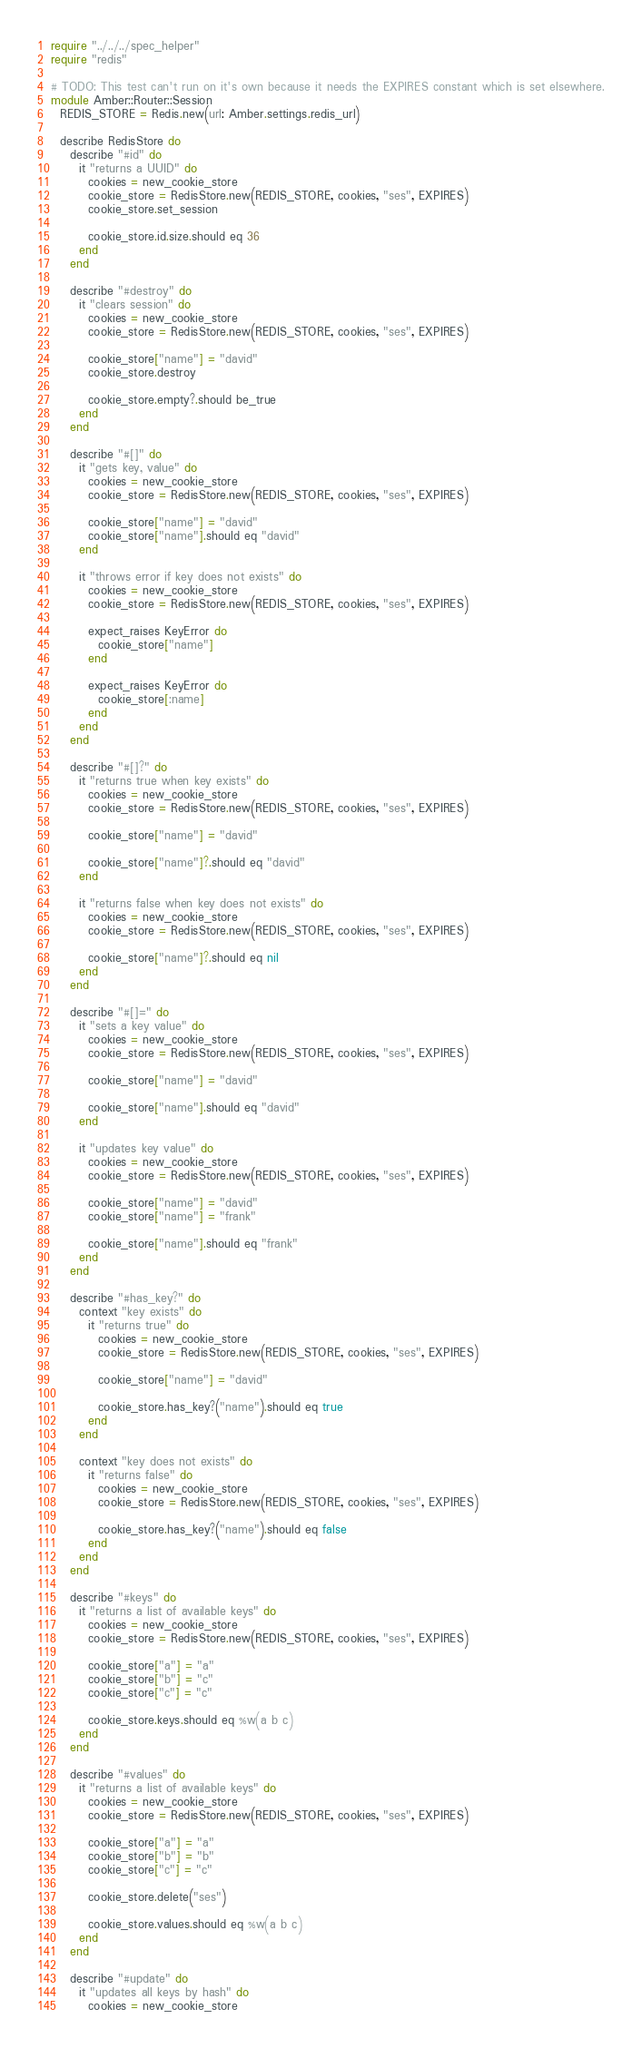<code> <loc_0><loc_0><loc_500><loc_500><_Crystal_>require "../../../spec_helper"
require "redis"

# TODO: This test can't run on it's own because it needs the EXPIRES constant which is set elsewhere.
module Amber::Router::Session
  REDIS_STORE = Redis.new(url: Amber.settings.redis_url)

  describe RedisStore do
    describe "#id" do
      it "returns a UUID" do
        cookies = new_cookie_store
        cookie_store = RedisStore.new(REDIS_STORE, cookies, "ses", EXPIRES)
        cookie_store.set_session

        cookie_store.id.size.should eq 36
      end
    end

    describe "#destroy" do
      it "clears session" do
        cookies = new_cookie_store
        cookie_store = RedisStore.new(REDIS_STORE, cookies, "ses", EXPIRES)

        cookie_store["name"] = "david"
        cookie_store.destroy

        cookie_store.empty?.should be_true
      end
    end

    describe "#[]" do
      it "gets key, value" do
        cookies = new_cookie_store
        cookie_store = RedisStore.new(REDIS_STORE, cookies, "ses", EXPIRES)

        cookie_store["name"] = "david"
        cookie_store["name"].should eq "david"
      end

      it "throws error if key does not exists" do
        cookies = new_cookie_store
        cookie_store = RedisStore.new(REDIS_STORE, cookies, "ses", EXPIRES)

        expect_raises KeyError do
          cookie_store["name"]
        end

        expect_raises KeyError do
          cookie_store[:name]
        end
      end
    end

    describe "#[]?" do
      it "returns true when key exists" do
        cookies = new_cookie_store
        cookie_store = RedisStore.new(REDIS_STORE, cookies, "ses", EXPIRES)

        cookie_store["name"] = "david"

        cookie_store["name"]?.should eq "david"
      end

      it "returns false when key does not exists" do
        cookies = new_cookie_store
        cookie_store = RedisStore.new(REDIS_STORE, cookies, "ses", EXPIRES)

        cookie_store["name"]?.should eq nil
      end
    end

    describe "#[]=" do
      it "sets a key value" do
        cookies = new_cookie_store
        cookie_store = RedisStore.new(REDIS_STORE, cookies, "ses", EXPIRES)

        cookie_store["name"] = "david"

        cookie_store["name"].should eq "david"
      end

      it "updates key value" do
        cookies = new_cookie_store
        cookie_store = RedisStore.new(REDIS_STORE, cookies, "ses", EXPIRES)

        cookie_store["name"] = "david"
        cookie_store["name"] = "frank"

        cookie_store["name"].should eq "frank"
      end
    end

    describe "#has_key?" do
      context "key exists" do
        it "returns true" do
          cookies = new_cookie_store
          cookie_store = RedisStore.new(REDIS_STORE, cookies, "ses", EXPIRES)

          cookie_store["name"] = "david"

          cookie_store.has_key?("name").should eq true
        end
      end

      context "key does not exists" do
        it "returns false" do
          cookies = new_cookie_store
          cookie_store = RedisStore.new(REDIS_STORE, cookies, "ses", EXPIRES)

          cookie_store.has_key?("name").should eq false
        end
      end
    end

    describe "#keys" do
      it "returns a list of available keys" do
        cookies = new_cookie_store
        cookie_store = RedisStore.new(REDIS_STORE, cookies, "ses", EXPIRES)

        cookie_store["a"] = "a"
        cookie_store["b"] = "c"
        cookie_store["c"] = "c"

        cookie_store.keys.should eq %w(a b c)
      end
    end

    describe "#values" do
      it "returns a list of available keys" do
        cookies = new_cookie_store
        cookie_store = RedisStore.new(REDIS_STORE, cookies, "ses", EXPIRES)

        cookie_store["a"] = "a"
        cookie_store["b"] = "b"
        cookie_store["c"] = "c"

        cookie_store.delete("ses")

        cookie_store.values.should eq %w(a b c)
      end
    end

    describe "#update" do
      it "updates all keys by hash" do
        cookies = new_cookie_store</code> 